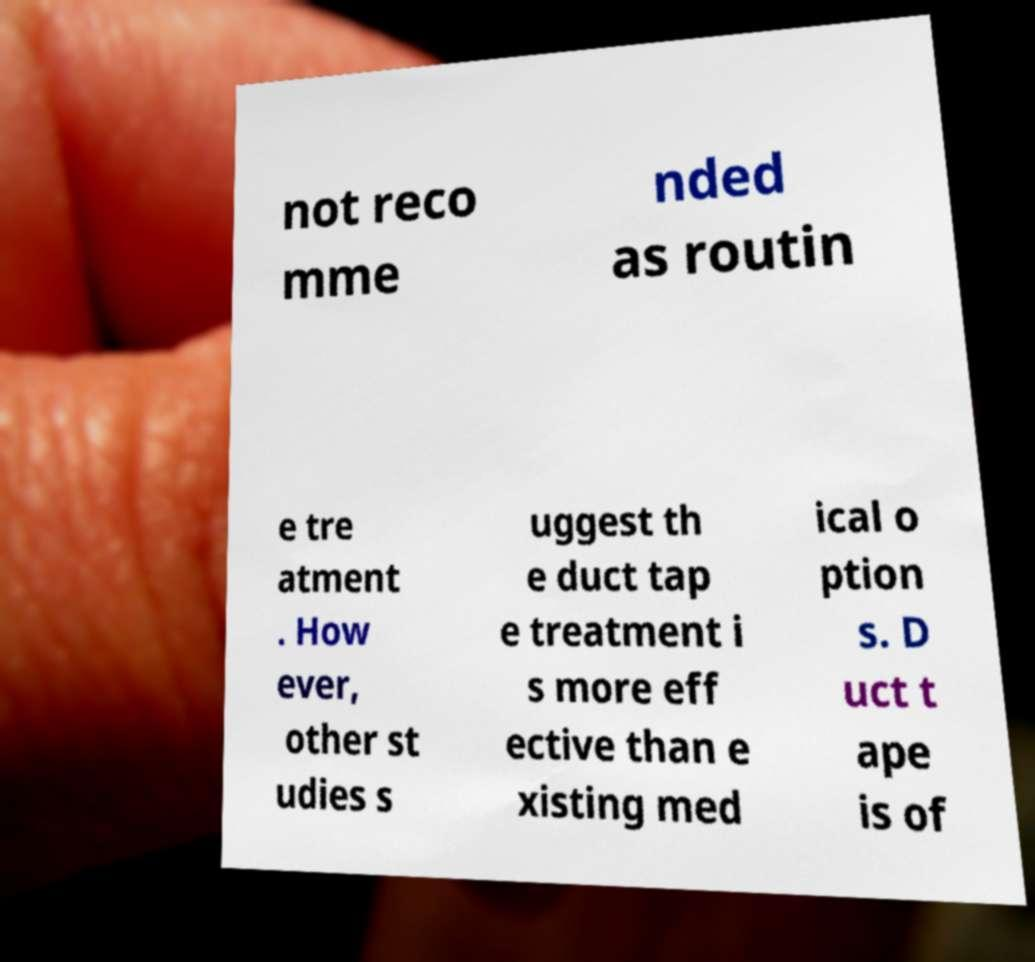Please read and relay the text visible in this image. What does it say? not reco mme nded as routin e tre atment . How ever, other st udies s uggest th e duct tap e treatment i s more eff ective than e xisting med ical o ption s. D uct t ape is of 